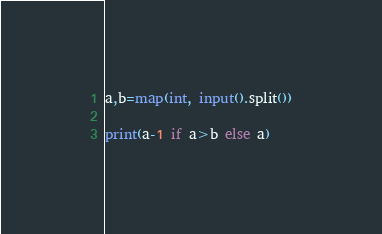Convert code to text. <code><loc_0><loc_0><loc_500><loc_500><_Python_>a,b=map(int, input().split())

print(a-1 if a>b else a)</code> 